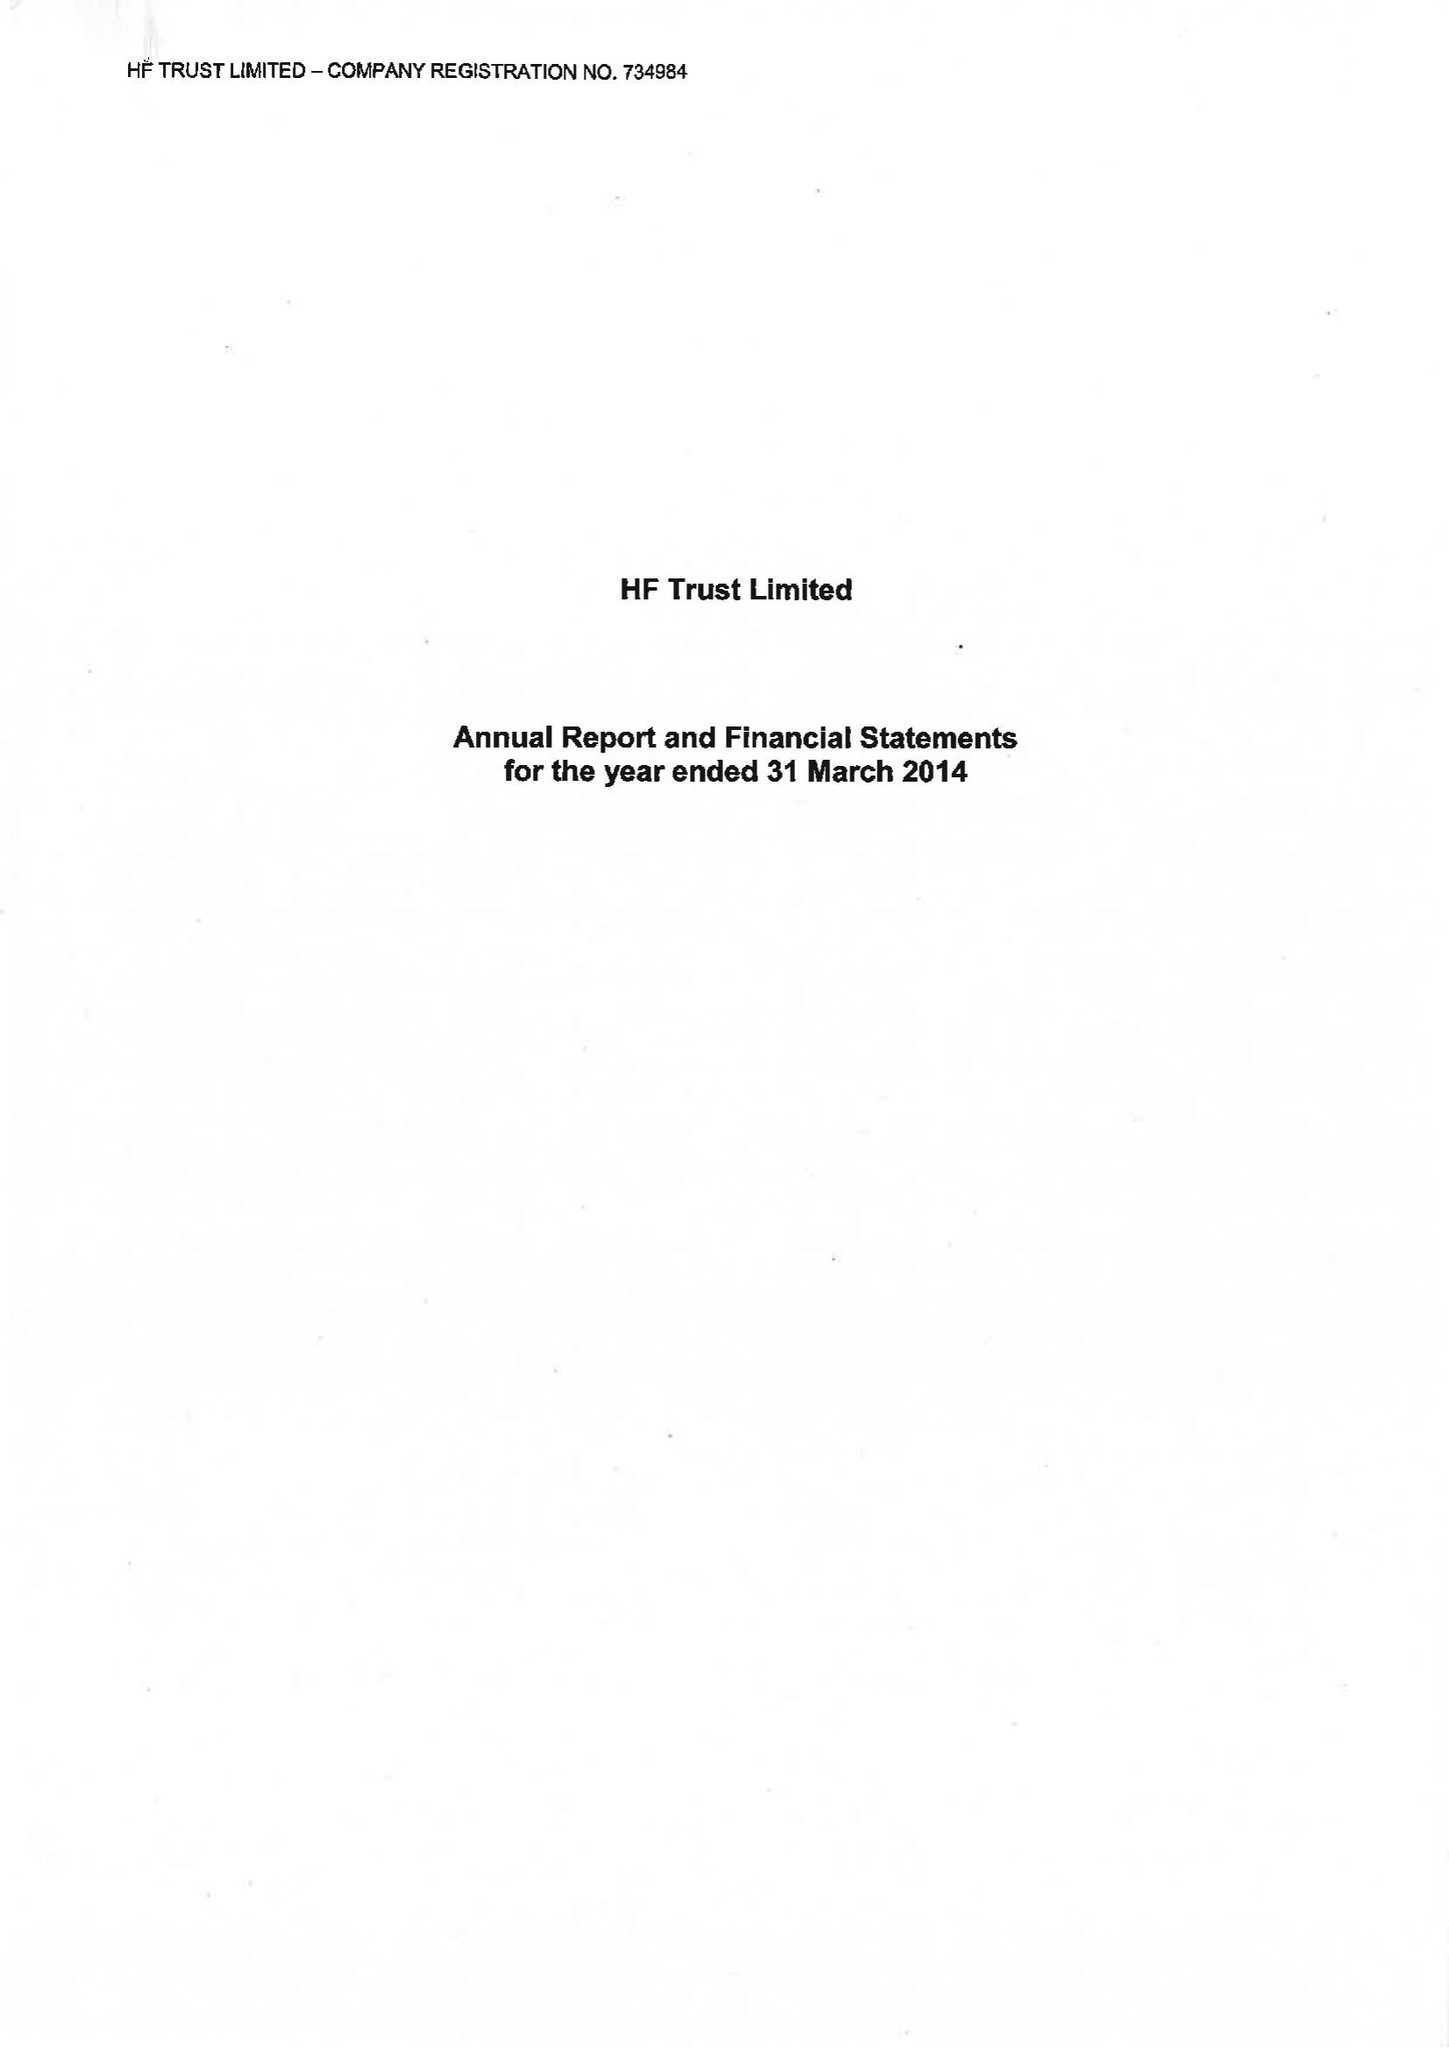What is the value for the report_date?
Answer the question using a single word or phrase. 2014-03-31 